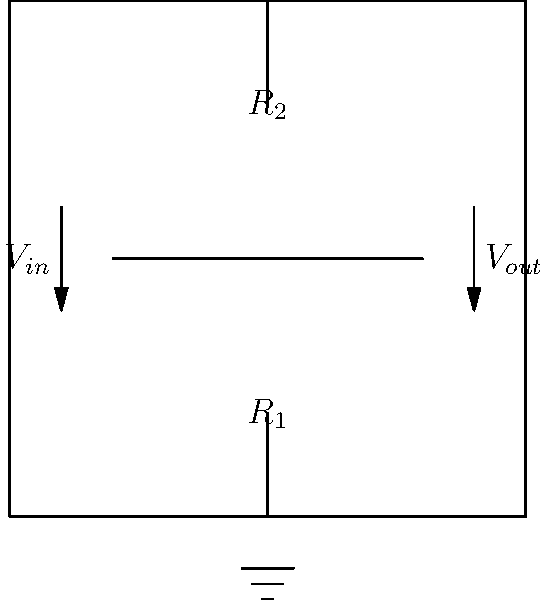In the given voltage amplifier circuit diagram, if $R_1 = 1k\Omega$ and $R_2 = 9k\Omega$, what is the voltage gain (Av) of this non-inverting amplifier configuration? To find the voltage gain (Av) of this non-inverting amplifier configuration, we can follow these steps:

1. Identify the circuit topology: This is a non-inverting operational amplifier configuration.

2. Recall the voltage gain formula for a non-inverting amplifier:
   $A_v = 1 + \frac{R_2}{R_1}$

3. Substitute the given values:
   $R_1 = 1k\Omega = 1000\Omega$
   $R_2 = 9k\Omega = 9000\Omega$

4. Calculate the voltage gain:
   $A_v = 1 + \frac{9000\Omega}{1000\Omega}$
   $A_v = 1 + 9$
   $A_v = 10$

5. Interpret the result: The voltage gain is 10, meaning the output voltage will be 10 times the input voltage.

This configuration is commonly used in audio amplifiers and other applications where a precise, fixed gain is required without inverting the signal.
Answer: 10 